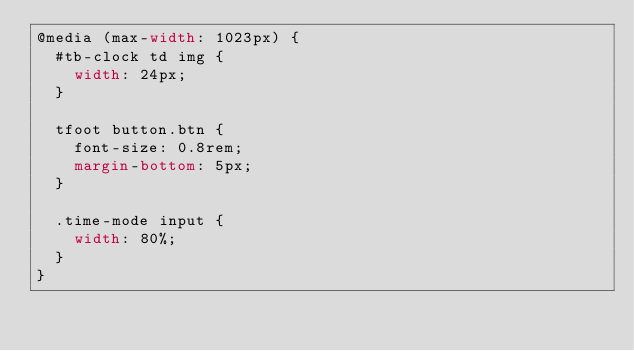<code> <loc_0><loc_0><loc_500><loc_500><_CSS_>@media (max-width: 1023px) {
  #tb-clock td img {
    width: 24px;
  }

  tfoot button.btn {
    font-size: 0.8rem;
    margin-bottom: 5px;
  }

  .time-mode input {
    width: 80%;
  }
}
</code> 